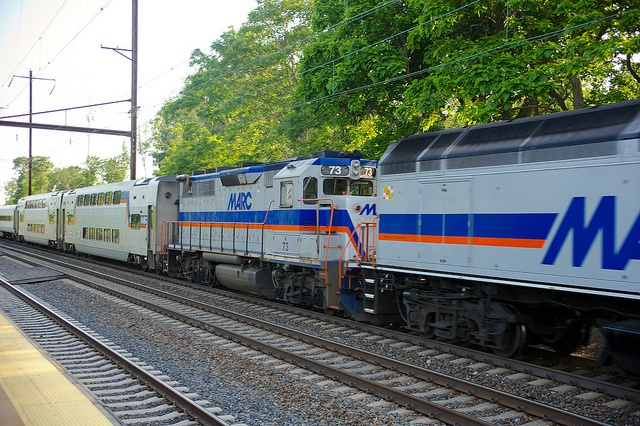Describe the objects in this image and their specific colors. I can see a train in lightblue, black, darkgray, gray, and darkblue tones in this image. 